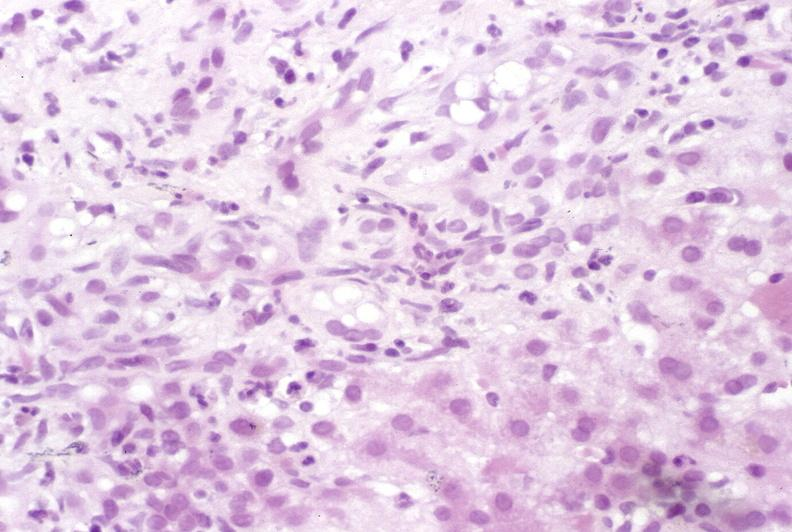does this image show primary sclerosing cholangitis?
Answer the question using a single word or phrase. Yes 